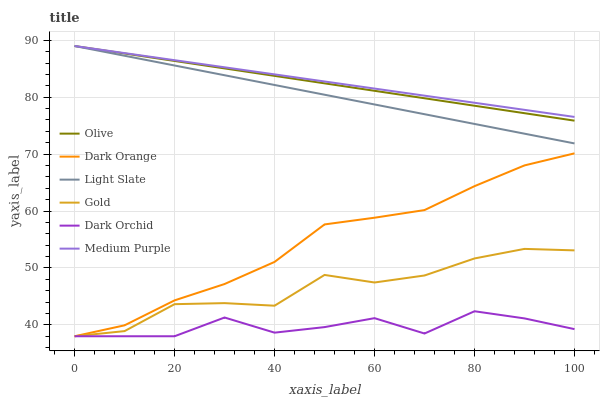Does Gold have the minimum area under the curve?
Answer yes or no. No. Does Gold have the maximum area under the curve?
Answer yes or no. No. Is Gold the smoothest?
Answer yes or no. No. Is Gold the roughest?
Answer yes or no. No. Does Light Slate have the lowest value?
Answer yes or no. No. Does Gold have the highest value?
Answer yes or no. No. Is Gold less than Olive?
Answer yes or no. Yes. Is Medium Purple greater than Dark Orchid?
Answer yes or no. Yes. Does Gold intersect Olive?
Answer yes or no. No. 